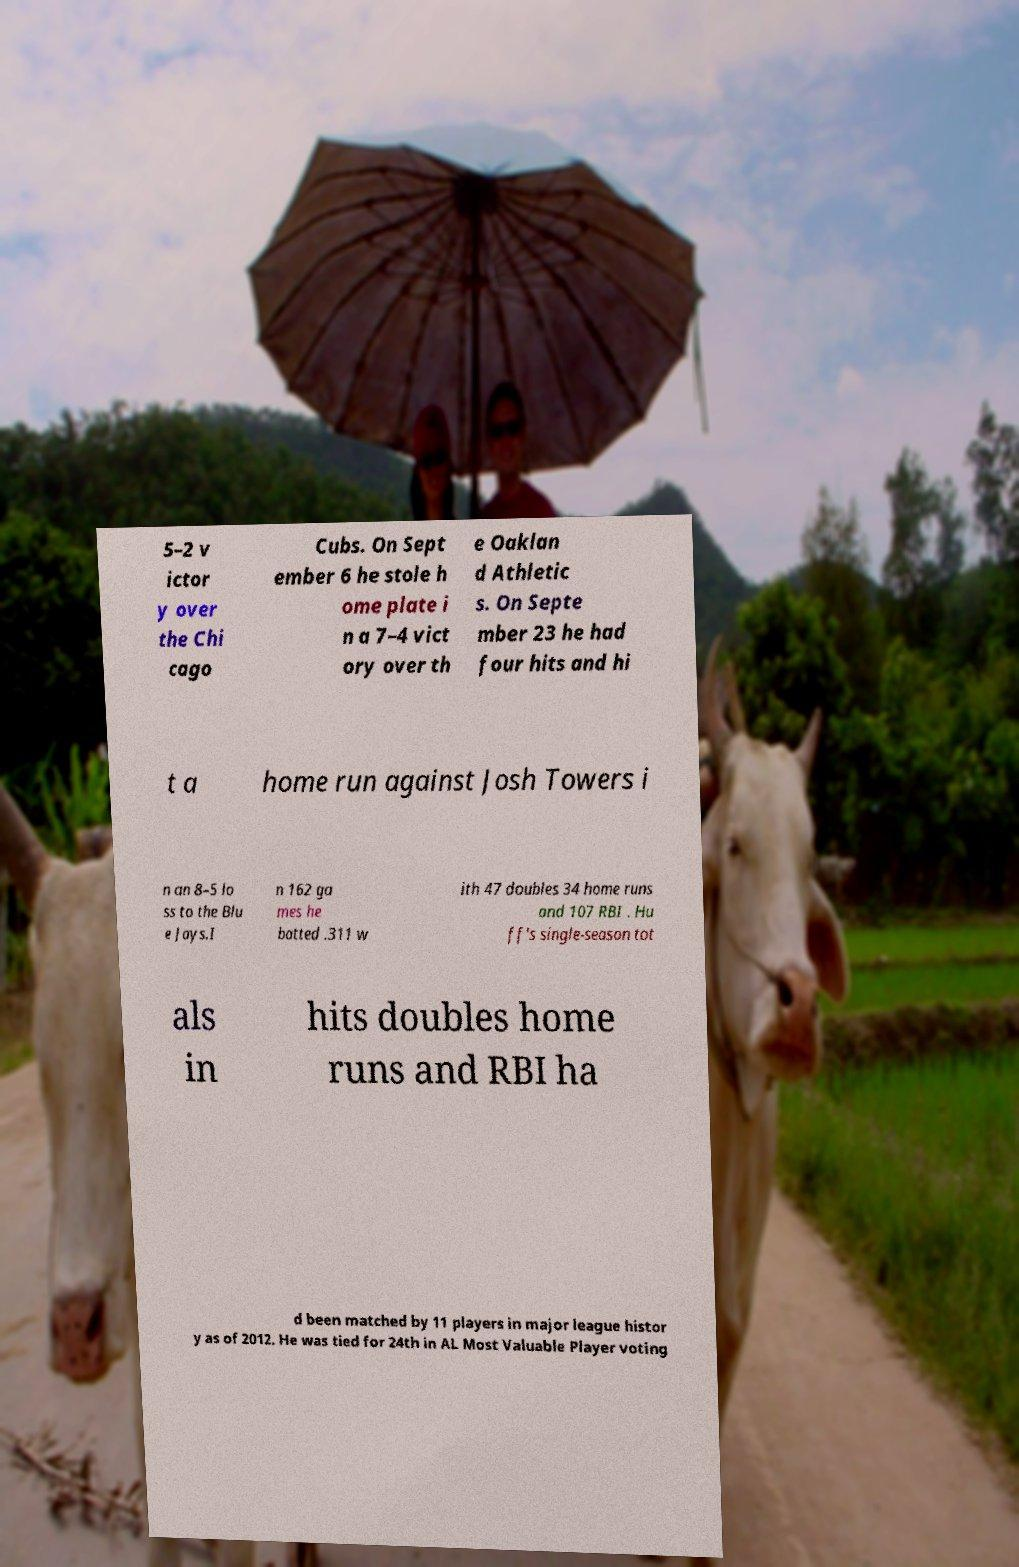Could you extract and type out the text from this image? 5–2 v ictor y over the Chi cago Cubs. On Sept ember 6 he stole h ome plate i n a 7–4 vict ory over th e Oaklan d Athletic s. On Septe mber 23 he had four hits and hi t a home run against Josh Towers i n an 8–5 lo ss to the Blu e Jays.I n 162 ga mes he batted .311 w ith 47 doubles 34 home runs and 107 RBI . Hu ff's single-season tot als in hits doubles home runs and RBI ha d been matched by 11 players in major league histor y as of 2012. He was tied for 24th in AL Most Valuable Player voting 